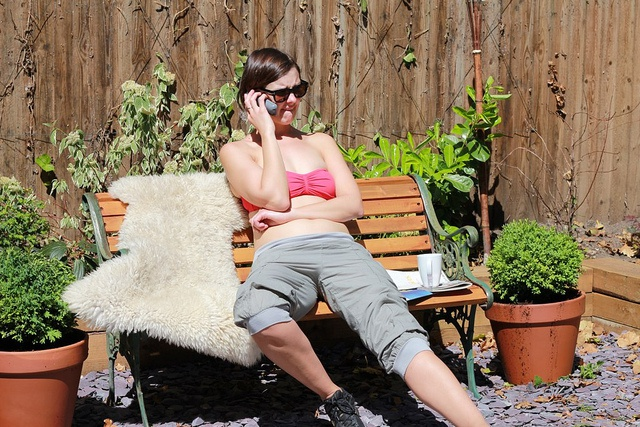Describe the objects in this image and their specific colors. I can see people in gray, lightgray, darkgray, lightpink, and tan tones, bench in gray, black, tan, and darkgray tones, potted plant in gray, black, brown, darkgreen, and olive tones, potted plant in gray, brown, black, and olive tones, and cup in gray, lightgray, and darkgray tones in this image. 